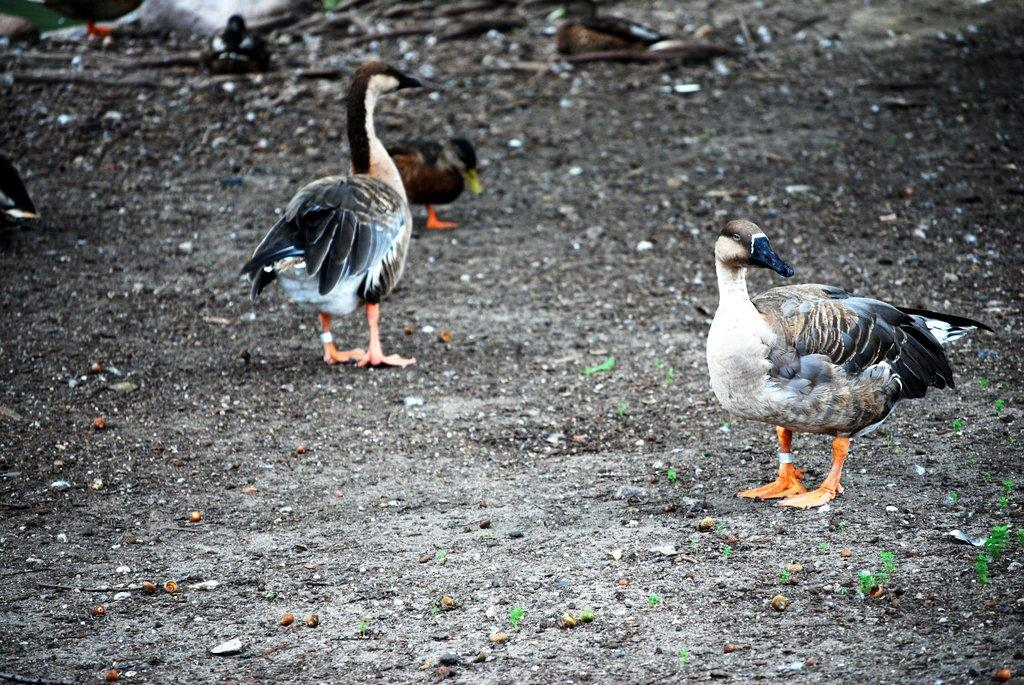What type of animals are on the ground in the image? There are ducks on the ground in the image. What else can be seen on the ground besides the ducks? There are small plants on the ground. Where is the argument taking place in the image? There is no argument present in the image; it features ducks and small plants on the ground. What type of performance is happening on the stage in the image? There is no stage present in the image; it only shows ducks and small plants on the ground. 